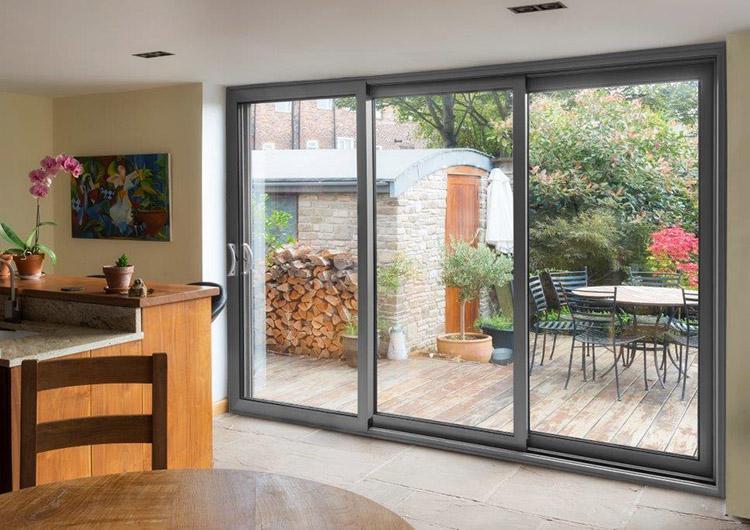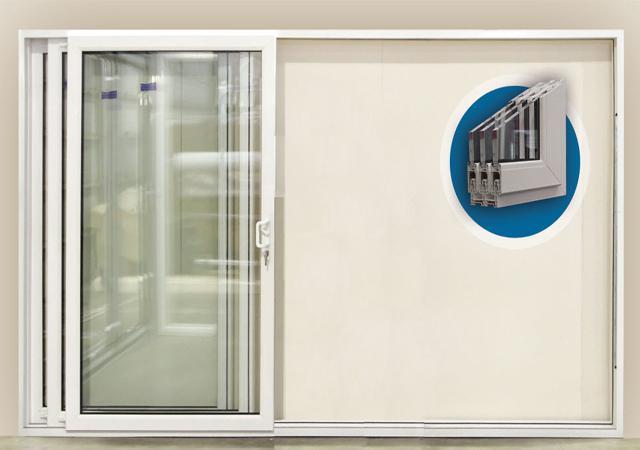The first image is the image on the left, the second image is the image on the right. For the images shown, is this caption "A woman is standing by the opening in the image on the left." true? Answer yes or no. No. The first image is the image on the left, the second image is the image on the right. Analyze the images presented: Is the assertion "An image shows one woman standing and touching a sliding door element." valid? Answer yes or no. No. 